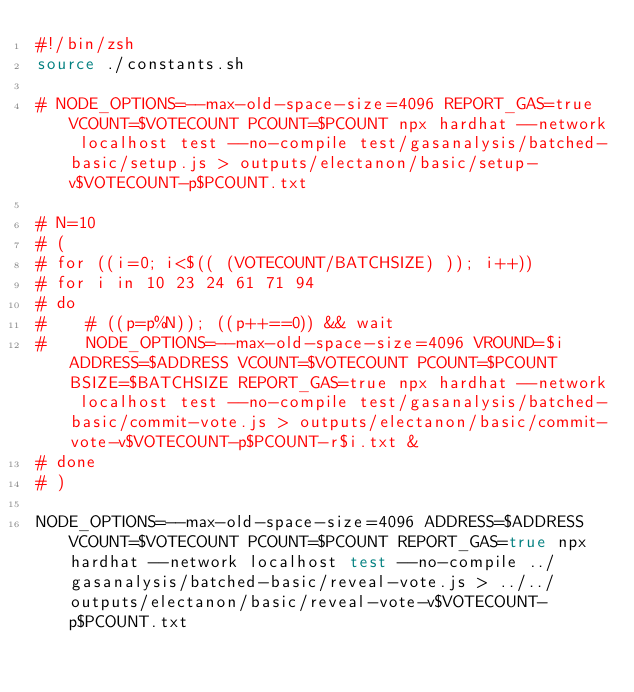<code> <loc_0><loc_0><loc_500><loc_500><_Bash_>#!/bin/zsh
source ./constants.sh

# NODE_OPTIONS=--max-old-space-size=4096 REPORT_GAS=true VCOUNT=$VOTECOUNT PCOUNT=$PCOUNT npx hardhat --network localhost test --no-compile test/gasanalysis/batched-basic/setup.js > outputs/electanon/basic/setup-v$VOTECOUNT-p$PCOUNT.txt

# N=10
# (
# for ((i=0; i<$(( (VOTECOUNT/BATCHSIZE) )); i++))
# for i in 10 23 24 61 71 94
# do
#    # ((p=p%N)); ((p++==0)) && wait
#    NODE_OPTIONS=--max-old-space-size=4096 VROUND=$i ADDRESS=$ADDRESS VCOUNT=$VOTECOUNT PCOUNT=$PCOUNT BSIZE=$BATCHSIZE REPORT_GAS=true npx hardhat --network localhost test --no-compile test/gasanalysis/batched-basic/commit-vote.js > outputs/electanon/basic/commit-vote-v$VOTECOUNT-p$PCOUNT-r$i.txt &
# done
# )

NODE_OPTIONS=--max-old-space-size=4096 ADDRESS=$ADDRESS VCOUNT=$VOTECOUNT PCOUNT=$PCOUNT REPORT_GAS=true npx hardhat --network localhost test --no-compile ../gasanalysis/batched-basic/reveal-vote.js > ../../outputs/electanon/basic/reveal-vote-v$VOTECOUNT-p$PCOUNT.txt
</code> 